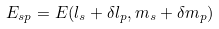<formula> <loc_0><loc_0><loc_500><loc_500>E _ { s p } = E ( l _ { s } + \delta l _ { p } , m _ { s } + \delta m _ { p } )</formula> 